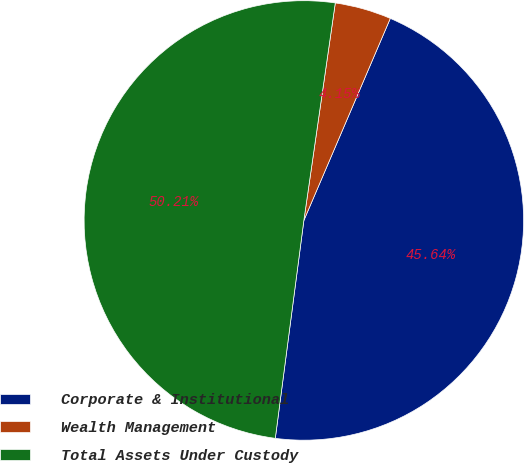<chart> <loc_0><loc_0><loc_500><loc_500><pie_chart><fcel>Corporate & Institutional<fcel>Wealth Management<fcel>Total Assets Under Custody<nl><fcel>45.64%<fcel>4.15%<fcel>50.21%<nl></chart> 